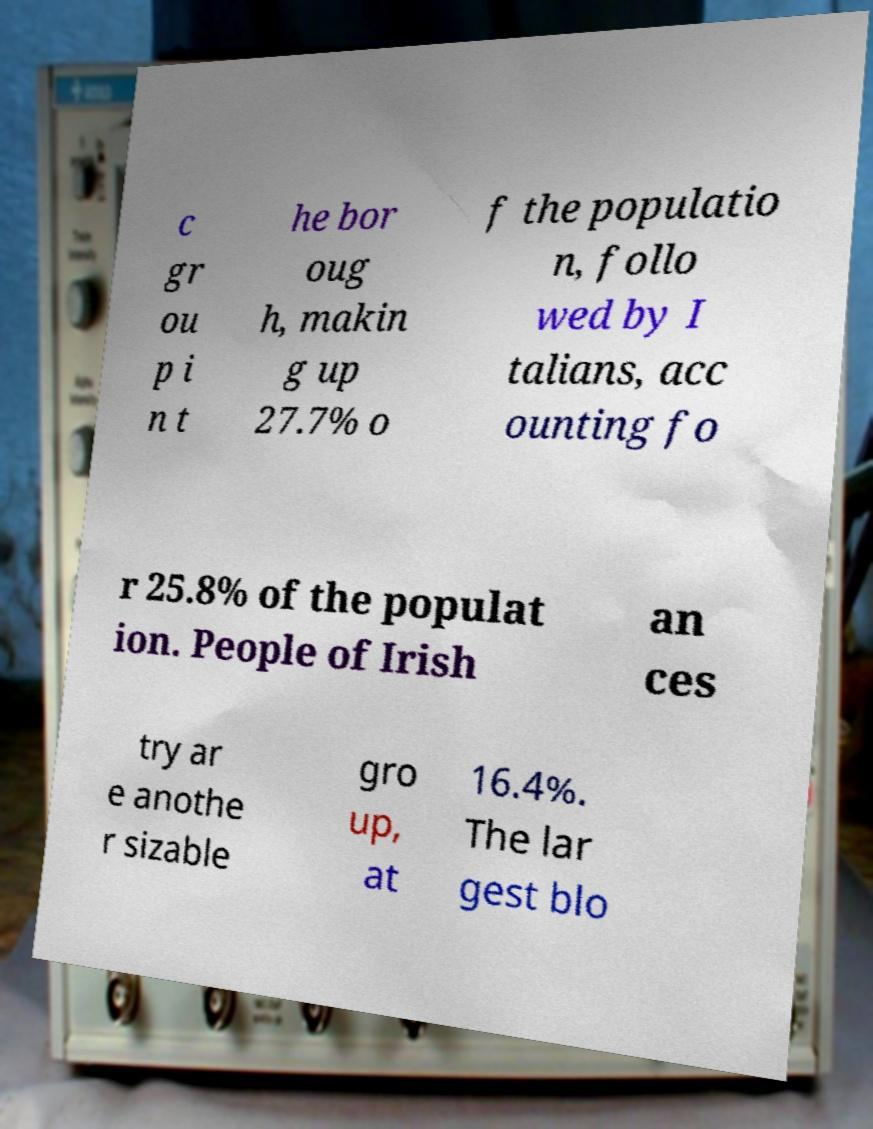Can you read and provide the text displayed in the image?This photo seems to have some interesting text. Can you extract and type it out for me? c gr ou p i n t he bor oug h, makin g up 27.7% o f the populatio n, follo wed by I talians, acc ounting fo r 25.8% of the populat ion. People of Irish an ces try ar e anothe r sizable gro up, at 16.4%. The lar gest blo 